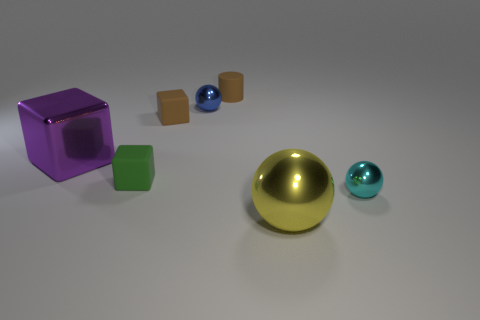There is a green rubber thing that is the same size as the blue object; what is its shape? cube 